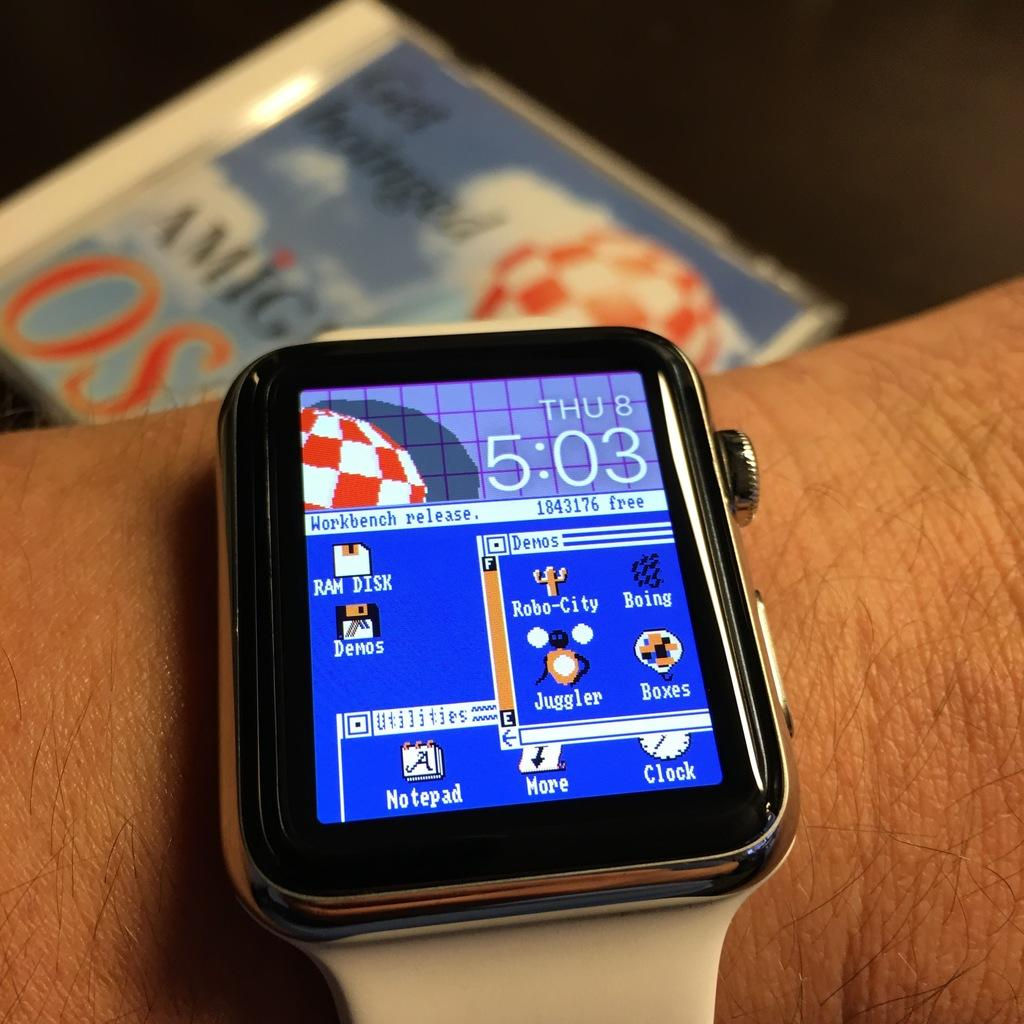<image>
Offer a succinct explanation of the picture presented. A smart watch that tells it is Thursday 8th at 5:03. 